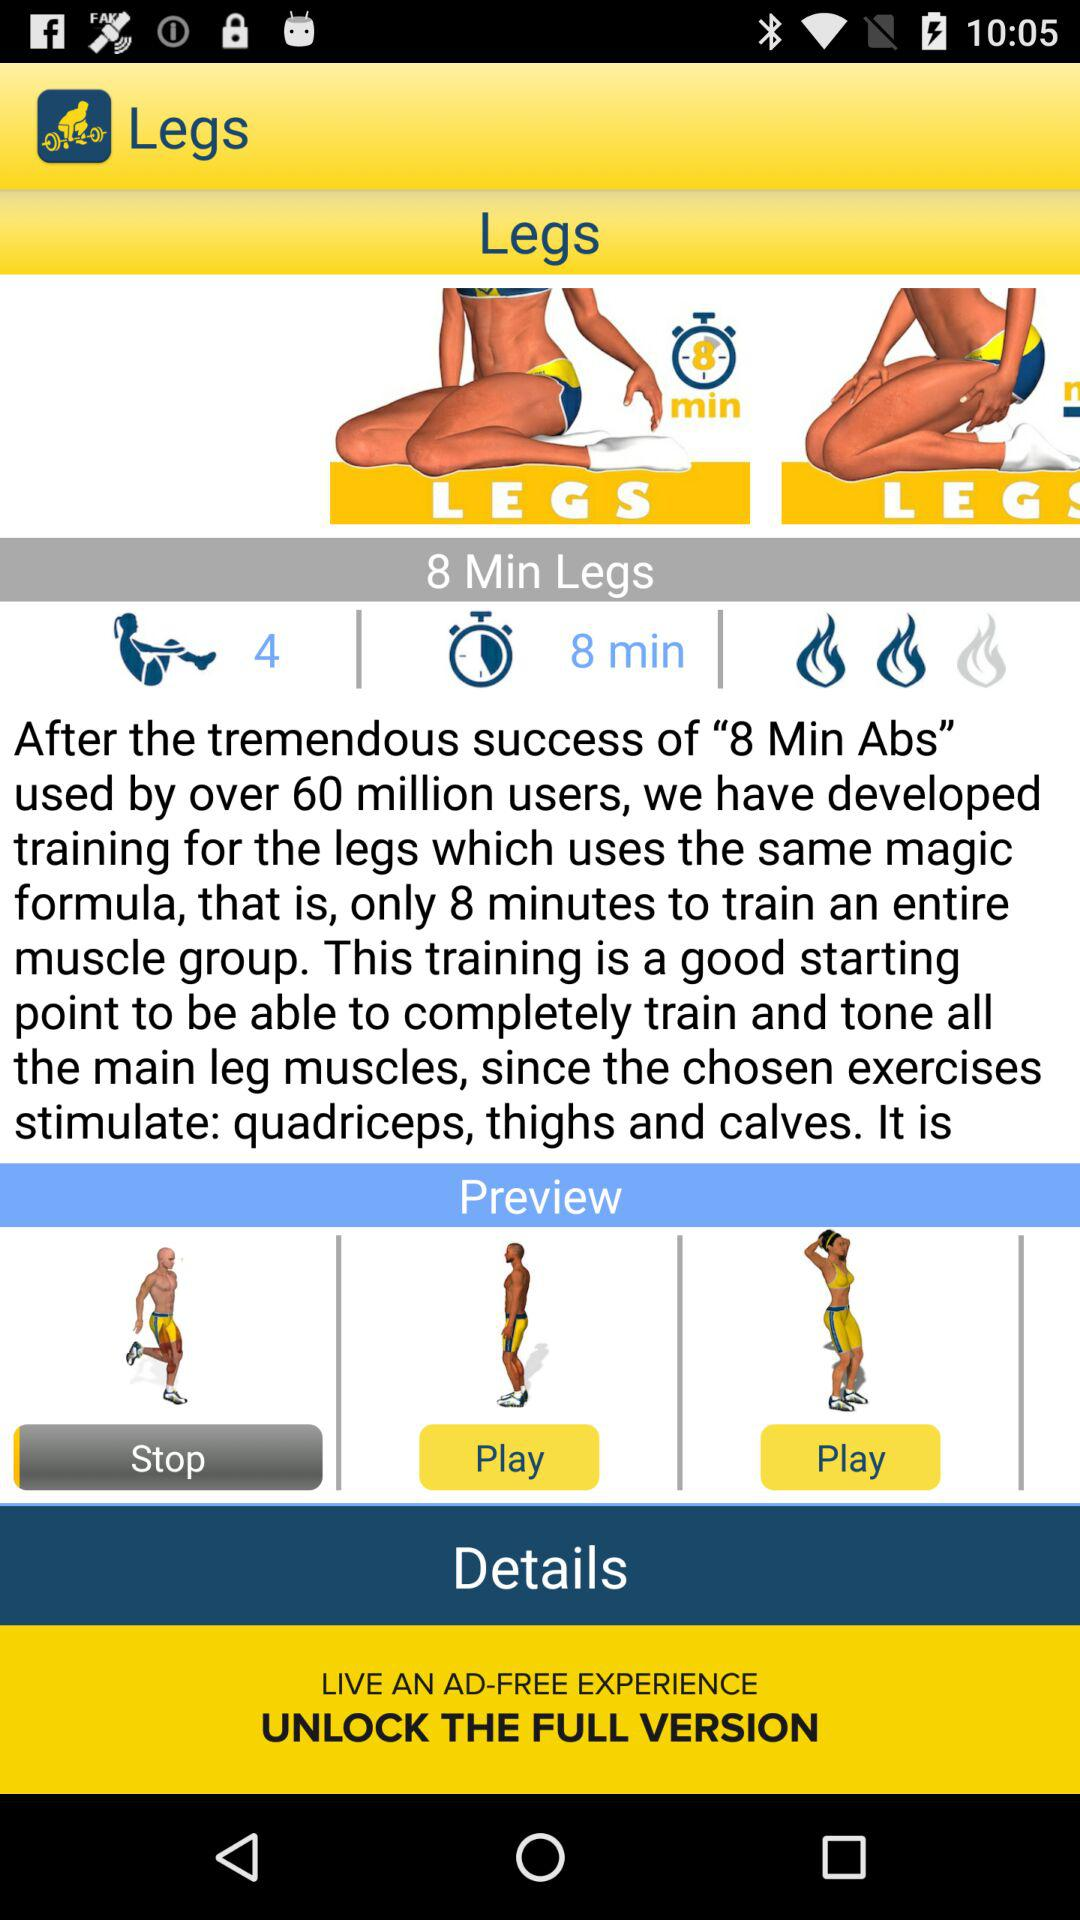How many more minutes are there in the workout than exercises?
Answer the question using a single word or phrase. 4 